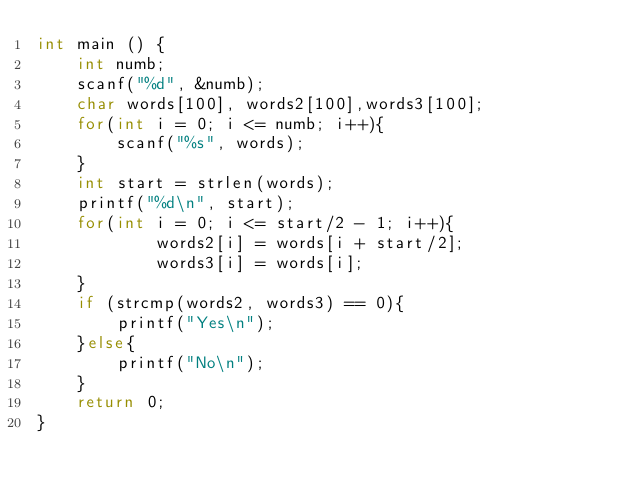Convert code to text. <code><loc_0><loc_0><loc_500><loc_500><_C_>int main () {
    int numb;
    scanf("%d", &numb);
    char words[100], words2[100],words3[100];
    for(int i = 0; i <= numb; i++){
        scanf("%s", words);
    }
    int start = strlen(words);
    printf("%d\n", start);
    for(int i = 0; i <= start/2 - 1; i++){
            words2[i] = words[i + start/2];
            words3[i] = words[i];
    }
    if (strcmp(words2, words3) == 0){
        printf("Yes\n");
    }else{
        printf("No\n");
    }
    return 0;
}</code> 